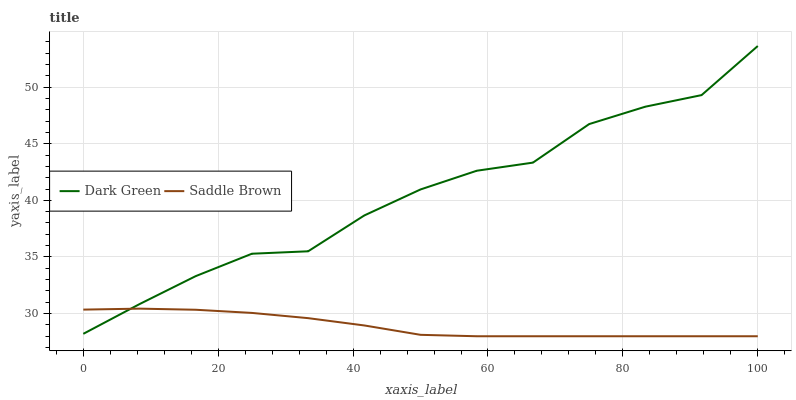Does Dark Green have the minimum area under the curve?
Answer yes or no. No. Is Dark Green the smoothest?
Answer yes or no. No. Does Dark Green have the lowest value?
Answer yes or no. No. 